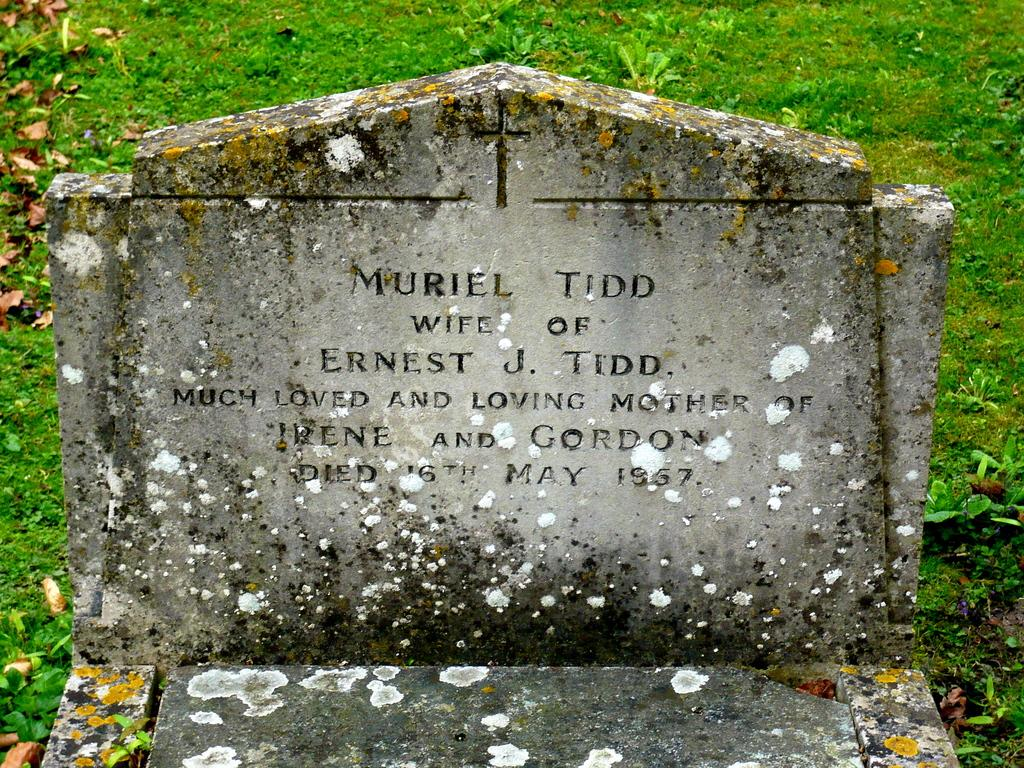What is the main subject of the picture? The main subject of the picture is a grave. Can you provide any information about the person buried in the grave? The grave belongs to a woman. What can be seen in the background of the picture? There is green grass behind the grave. What type of mask is the woman wearing in the picture? There is no mask present in the picture, as it features a grave and not a living person. 